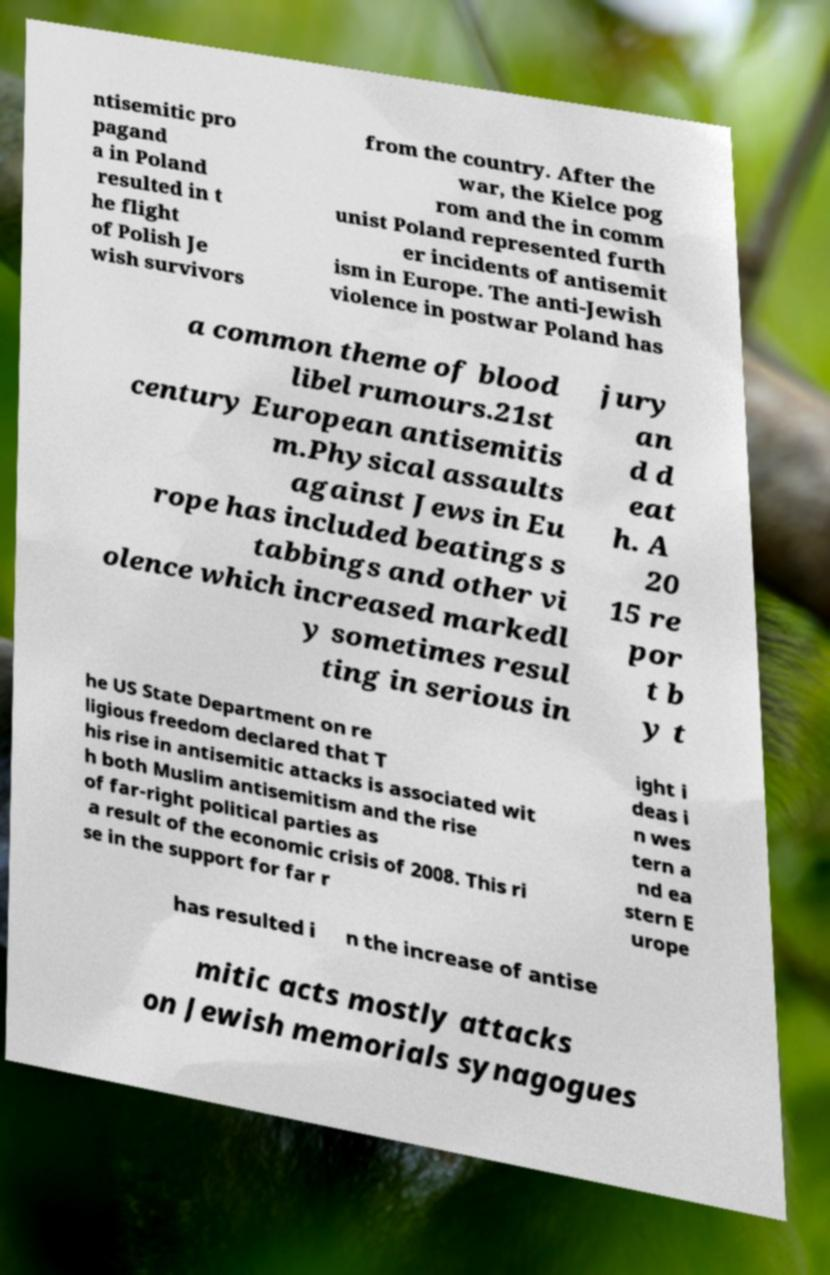I need the written content from this picture converted into text. Can you do that? ntisemitic pro pagand a in Poland resulted in t he flight of Polish Je wish survivors from the country. After the war, the Kielce pog rom and the in comm unist Poland represented furth er incidents of antisemit ism in Europe. The anti-Jewish violence in postwar Poland has a common theme of blood libel rumours.21st century European antisemitis m.Physical assaults against Jews in Eu rope has included beatings s tabbings and other vi olence which increased markedl y sometimes resul ting in serious in jury an d d eat h. A 20 15 re por t b y t he US State Department on re ligious freedom declared that T his rise in antisemitic attacks is associated wit h both Muslim antisemitism and the rise of far-right political parties as a result of the economic crisis of 2008. This ri se in the support for far r ight i deas i n wes tern a nd ea stern E urope has resulted i n the increase of antise mitic acts mostly attacks on Jewish memorials synagogues 